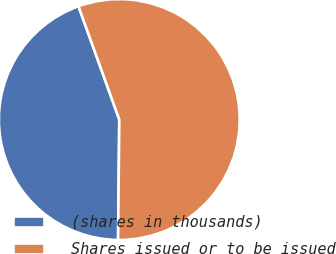<chart> <loc_0><loc_0><loc_500><loc_500><pie_chart><fcel>(shares in thousands)<fcel>Shares issued or to be issued<nl><fcel>44.34%<fcel>55.66%<nl></chart> 